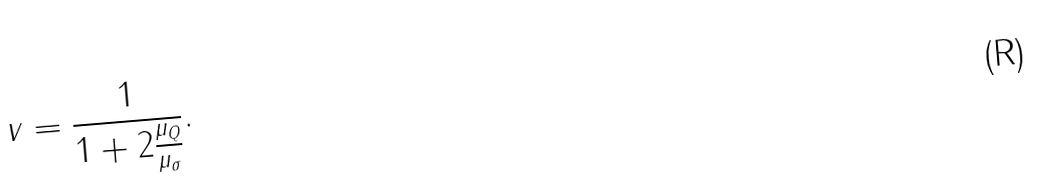Convert formula to latex. <formula><loc_0><loc_0><loc_500><loc_500>v = \frac { 1 } { 1 + 2 \frac { \mu _ { Q } } { \mu _ { \sigma } } } .</formula> 